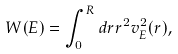Convert formula to latex. <formula><loc_0><loc_0><loc_500><loc_500>W ( E ) = \int _ { 0 } ^ { R } d r r ^ { 2 } v _ { E } ^ { 2 } ( r ) ,</formula> 